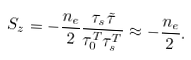<formula> <loc_0><loc_0><loc_500><loc_500>S _ { z } = - \frac { n _ { e } } { 2 } \frac { \tau _ { s } \tilde { \tau } } { \tau _ { 0 } ^ { T } \tau _ { s } ^ { T } } \approx - \frac { n _ { e } } { 2 } .</formula> 